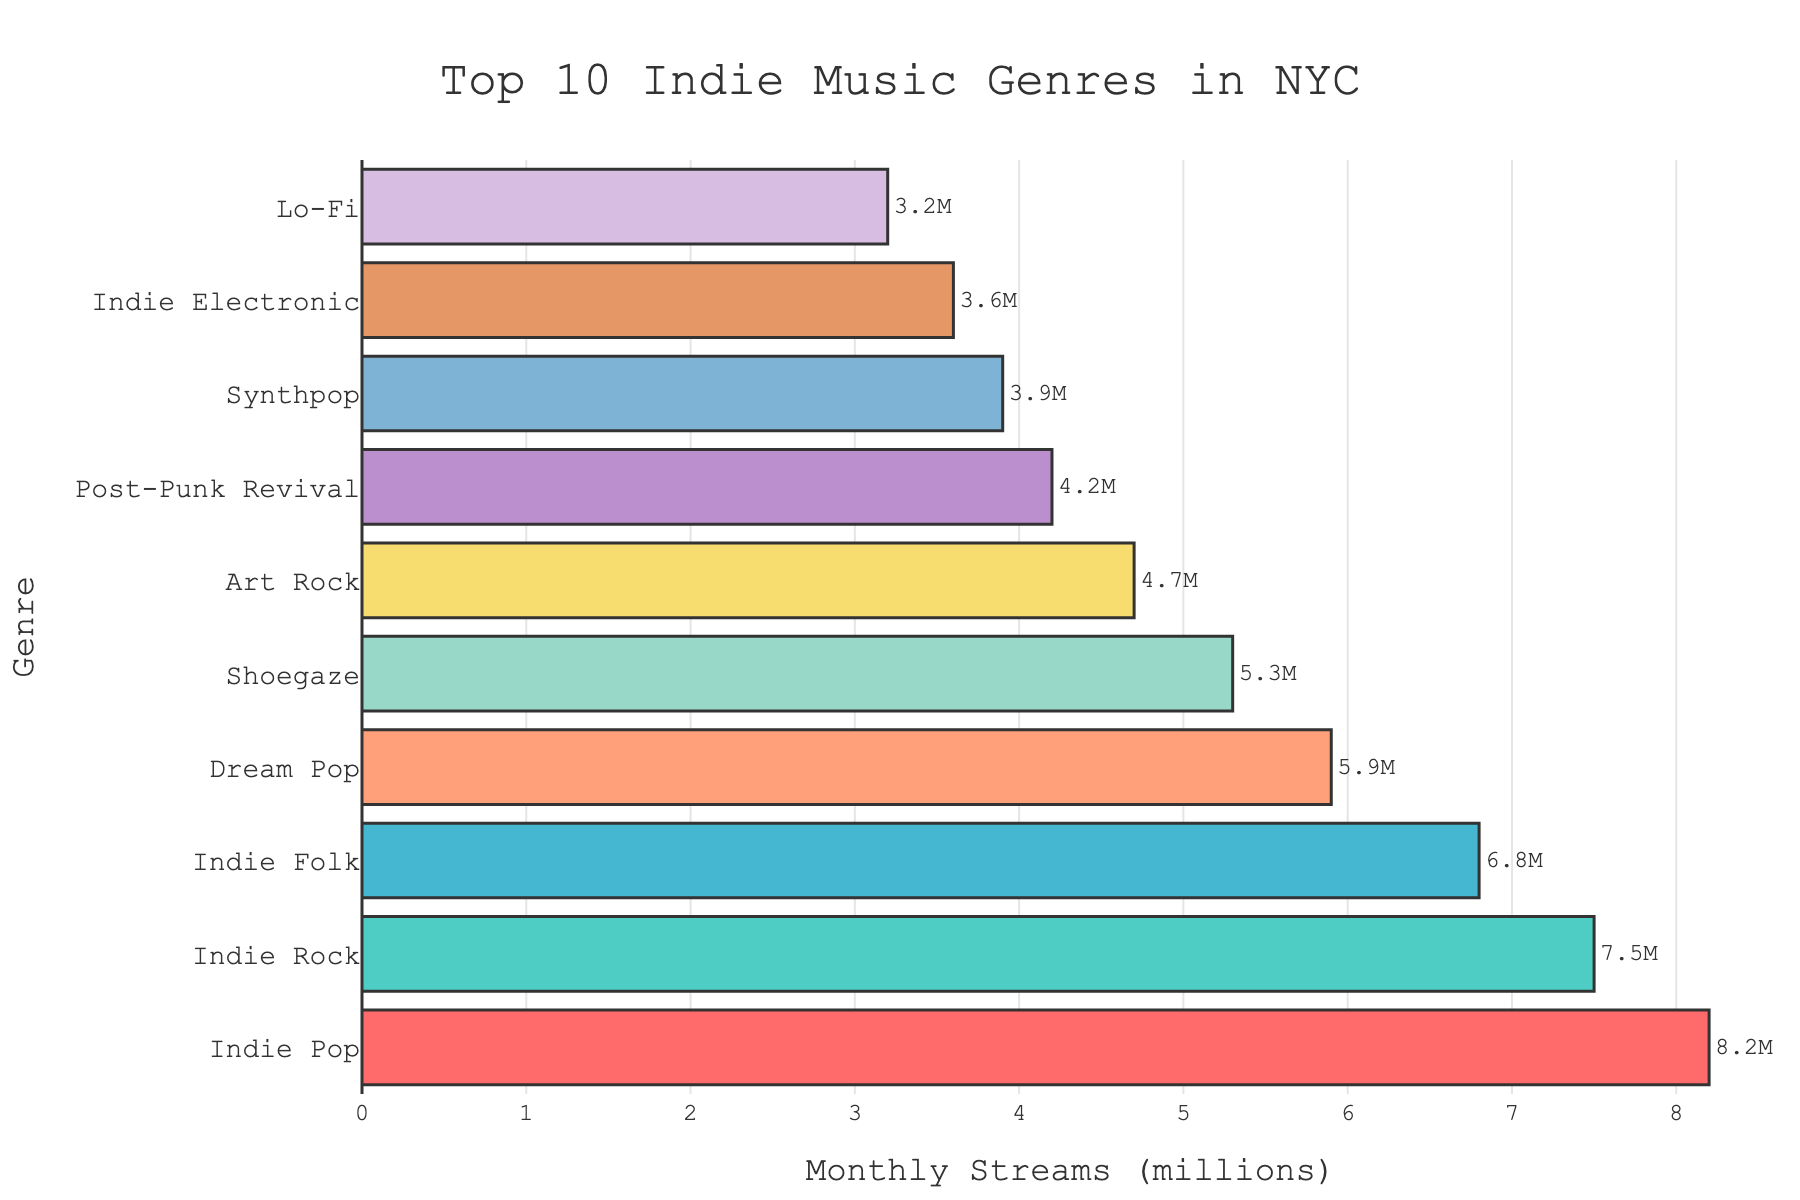What genre has the highest number of monthly streams? The genre with the highest number of monthly streams will be the tallest and most extended bar in the chart. By comparing the lengths of all bars, Indie Pop has the longest bar.
Answer: Indie Pop Which genre is streamed the least? The genre with the least number of monthly streams will have the shortest bar among all genres displayed. By looking at the bars, Lo-Fi has the shortest bar.
Answer: Lo-Fi How many more streams does Indie Rock have compared to Indie Folk? Identify the bars for Indie Rock and Indie Folk, check their lengths, and calculate the difference in their values. Indie Rock has 7.5M, and Indie Folk has 6.8M. The difference is 7.5 - 6.8 = 0.7M.
Answer: 0.7M What is the total number of monthly streams for the top three genres? Identify the top three genres by examining the three longest bars, which are Indie Pop (8.2M), Indie Rock (7.5M), and Indie Folk (6.8M). Then, sum these values: 8.2 + 7.5 + 6.8 = 22.5M.
Answer: 22.5M Which two genres have similar streaming numbers? Locate the pairs of bars that have similar lengths. Dream Pop (5.9M) and Shoegaze (5.3M) are relatively close in their values compared to other genres.
Answer: Dream Pop and Shoegaze What is the average number of monthly streams across all genres? Sum all the monthly streaming numbers and divide by the number of genres. The sum is 8.2 + 7.5 + 6.8 + 5.9 + 5.3 + 4.7 + 4.2 + 3.9 + 3.6 + 3.2 = 53.3M. There are 10 genres. So, the average is 53.3 / 10 = 5.33M.
Answer: 5.33M How many genres have more than 5 million streams per month? Count the number of bars with lengths representing more than 5 million streams. Indie Pop, Indie Rock, Indie Folk, Dream Pop, and Shoegaze all have more than 5M streams. There are 5 such genres.
Answer: 5 Compare the streams of Synthpop and Art Rock. Which one is higher, and by how much? Locate the bars for Synthpop and Art Rock, compare their lengths, and compute the difference. Synthpop has 3.9M, and Art Rock has 4.7M. Art Rock is higher by 4.7 - 3.9 = 0.8M.
Answer: Art Rock is higher by 0.8M 